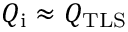<formula> <loc_0><loc_0><loc_500><loc_500>Q _ { i } \approx Q _ { T L S }</formula> 